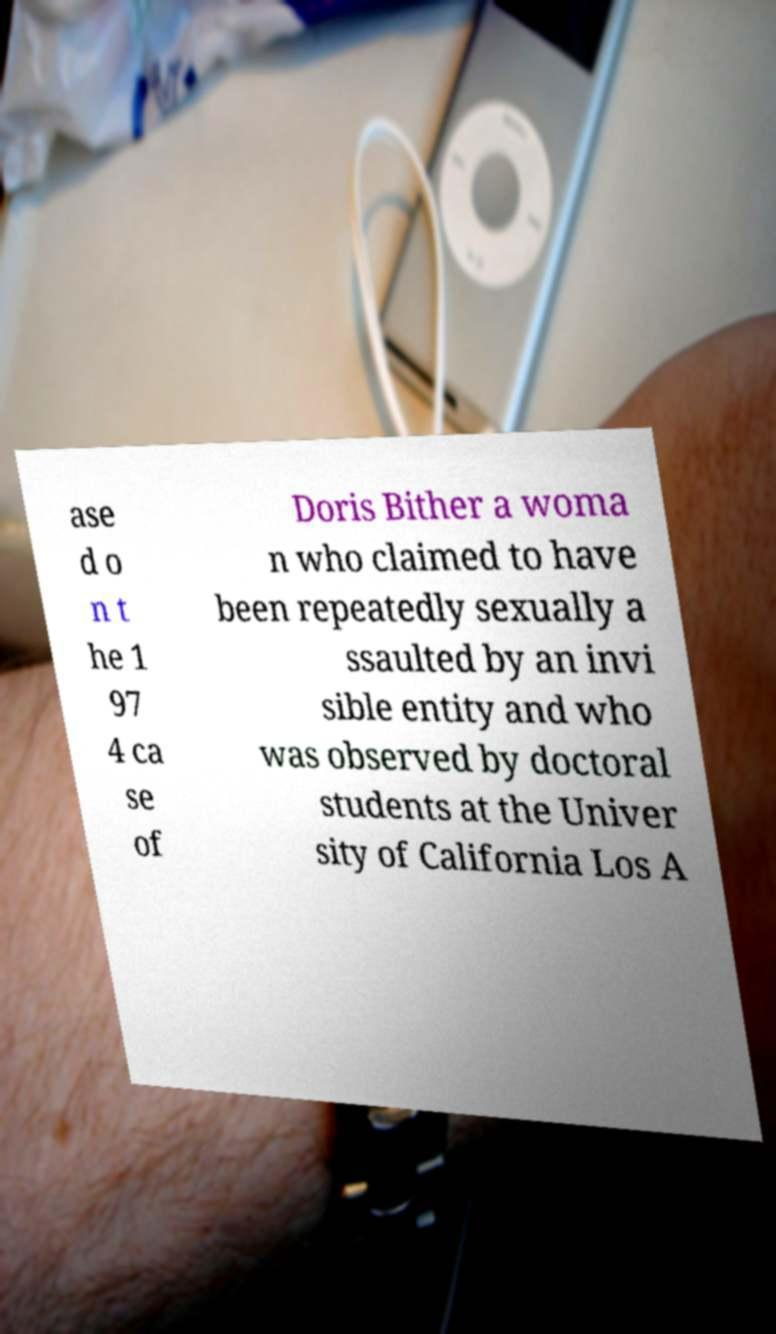Can you read and provide the text displayed in the image?This photo seems to have some interesting text. Can you extract and type it out for me? ase d o n t he 1 97 4 ca se of Doris Bither a woma n who claimed to have been repeatedly sexually a ssaulted by an invi sible entity and who was observed by doctoral students at the Univer sity of California Los A 